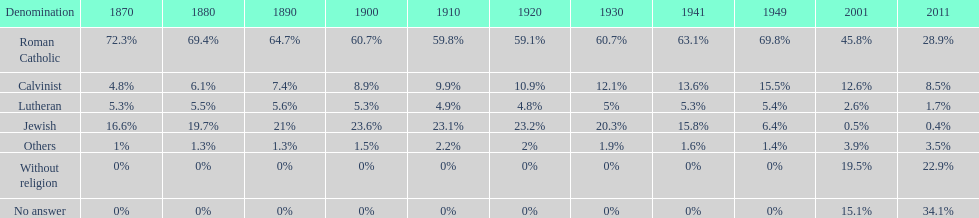Which denomination percentage increased the most after 1949? Without religion. 